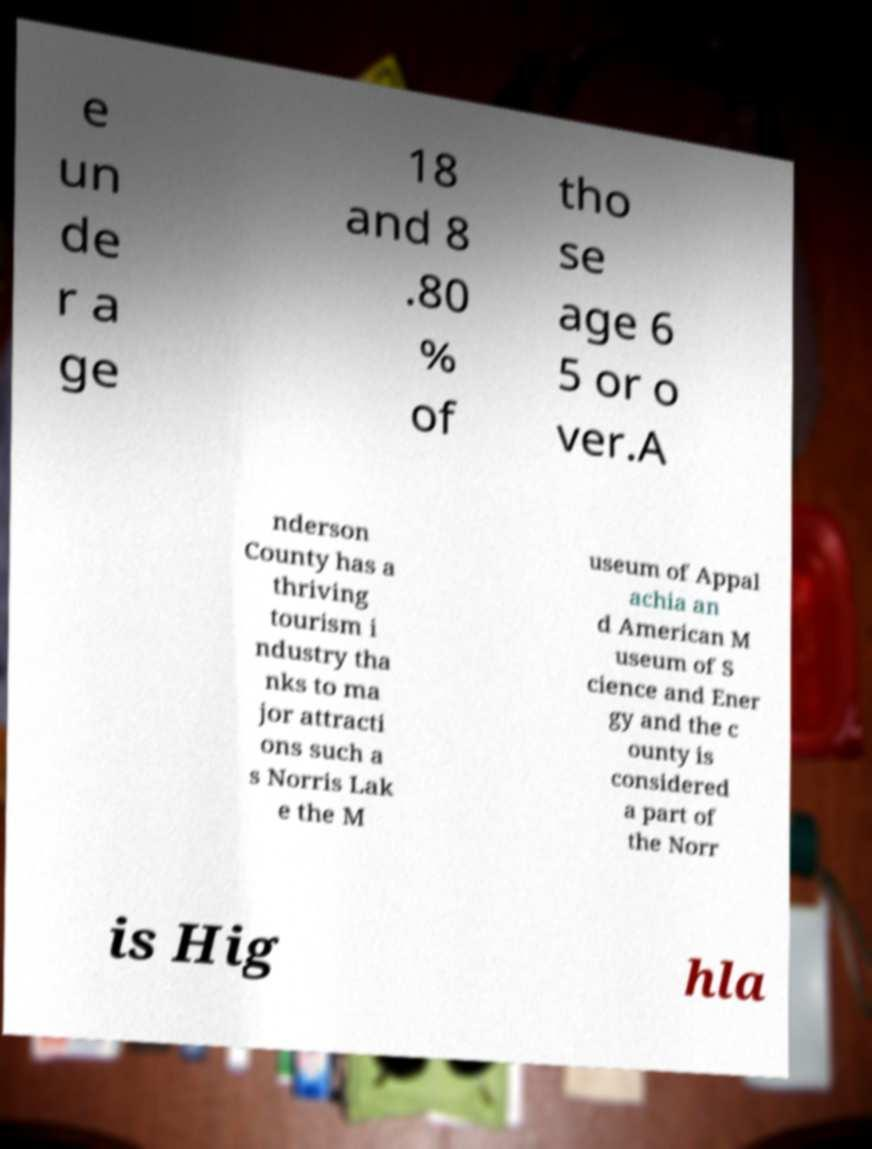Could you assist in decoding the text presented in this image and type it out clearly? e un de r a ge 18 and 8 .80 % of tho se age 6 5 or o ver.A nderson County has a thriving tourism i ndustry tha nks to ma jor attracti ons such a s Norris Lak e the M useum of Appal achia an d American M useum of S cience and Ener gy and the c ounty is considered a part of the Norr is Hig hla 